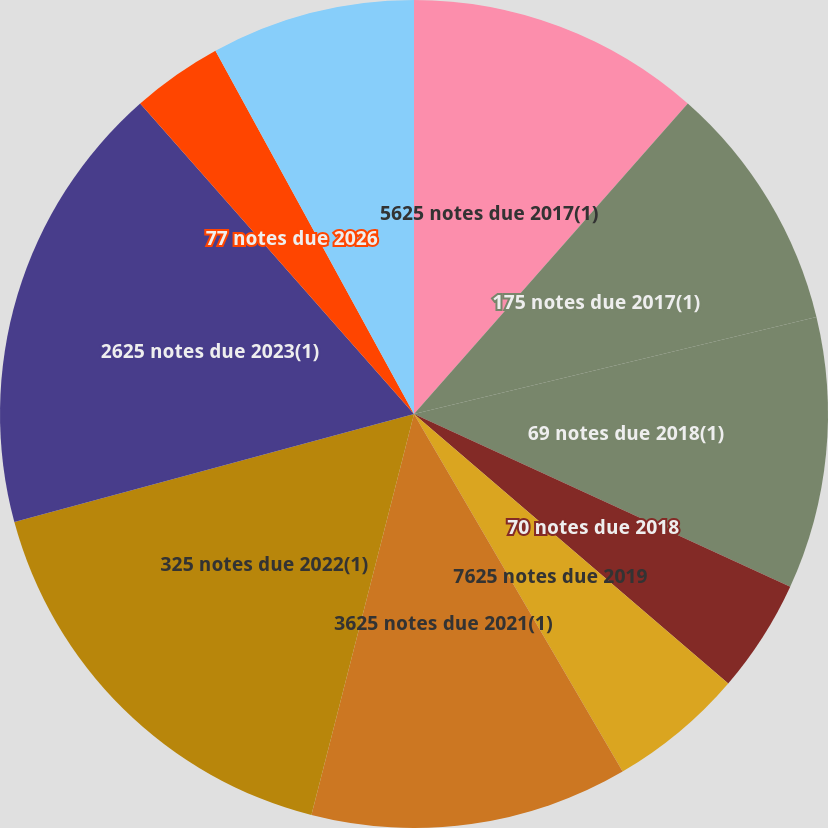<chart> <loc_0><loc_0><loc_500><loc_500><pie_chart><fcel>5625 notes due 2017(1)<fcel>175 notes due 2017(1)<fcel>69 notes due 2018(1)<fcel>70 notes due 2018<fcel>7625 notes due 2019<fcel>3625 notes due 2021(1)<fcel>325 notes due 2022(1)<fcel>2625 notes due 2023(1)<fcel>77 notes due 2026<fcel>795 notes due 2026<nl><fcel>11.5%<fcel>9.73%<fcel>10.62%<fcel>4.43%<fcel>5.31%<fcel>12.39%<fcel>16.81%<fcel>17.7%<fcel>3.54%<fcel>7.96%<nl></chart> 